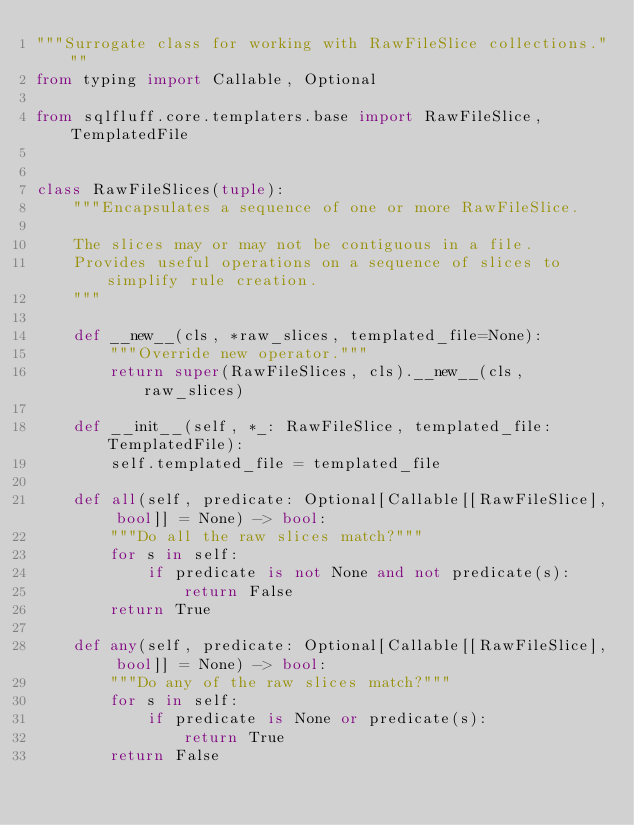<code> <loc_0><loc_0><loc_500><loc_500><_Python_>"""Surrogate class for working with RawFileSlice collections."""
from typing import Callable, Optional

from sqlfluff.core.templaters.base import RawFileSlice, TemplatedFile


class RawFileSlices(tuple):
    """Encapsulates a sequence of one or more RawFileSlice.

    The slices may or may not be contiguous in a file.
    Provides useful operations on a sequence of slices to simplify rule creation.
    """

    def __new__(cls, *raw_slices, templated_file=None):
        """Override new operator."""
        return super(RawFileSlices, cls).__new__(cls, raw_slices)

    def __init__(self, *_: RawFileSlice, templated_file: TemplatedFile):
        self.templated_file = templated_file

    def all(self, predicate: Optional[Callable[[RawFileSlice], bool]] = None) -> bool:
        """Do all the raw slices match?"""
        for s in self:
            if predicate is not None and not predicate(s):
                return False
        return True

    def any(self, predicate: Optional[Callable[[RawFileSlice], bool]] = None) -> bool:
        """Do any of the raw slices match?"""
        for s in self:
            if predicate is None or predicate(s):
                return True
        return False
</code> 